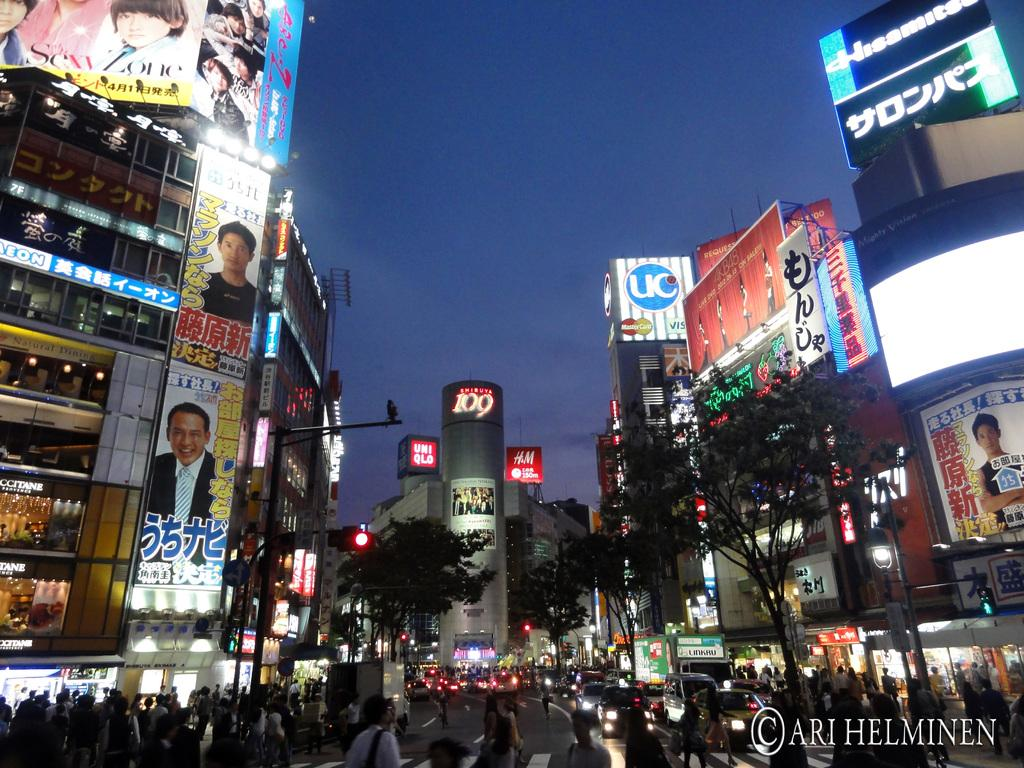What type of natural elements can be seen in the image? There are trees in the image. What type of man-made structures are visible in the image? There are light poles, buildings, and a hoarding in the image. What type of electronic device is present in the image? There is a screen in the image. Who or what is present in the image? There are people and vehicles in the image. What is visible in the background of the image? The sky is visible in the background of the image. Is there any additional information about the image itself? There is a watermark on the right side bottom of the image. Can you tell me how many ducks are swimming in the water in the image? There is no water or ducks present in the image. What type of waves can be seen in the image? There are no waves present in the image. 